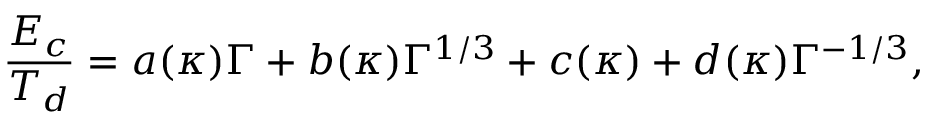Convert formula to latex. <formula><loc_0><loc_0><loc_500><loc_500>\frac { E _ { c } } { T _ { d } } = a ( \kappa ) \Gamma + b ( \kappa ) \Gamma ^ { 1 / 3 } + c ( \kappa ) + d ( \kappa ) \Gamma ^ { - 1 / 3 } ,</formula> 